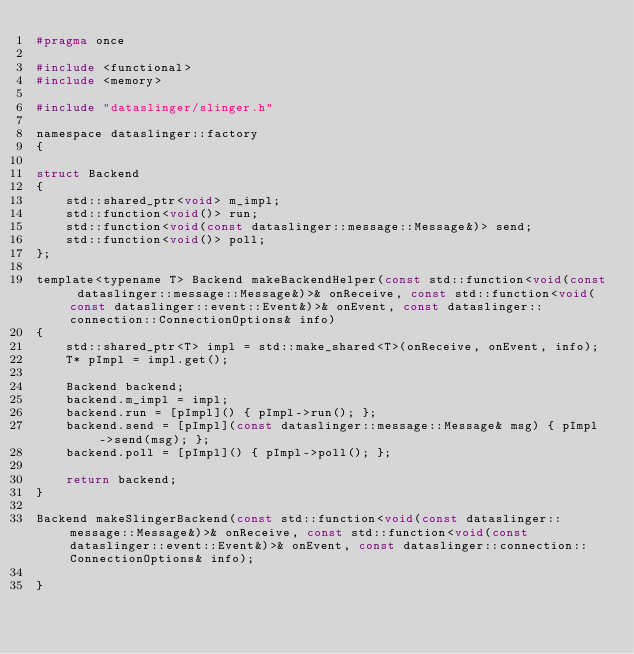Convert code to text. <code><loc_0><loc_0><loc_500><loc_500><_C_>#pragma once

#include <functional>
#include <memory>

#include "dataslinger/slinger.h"

namespace dataslinger::factory
{

struct Backend
{
    std::shared_ptr<void> m_impl;
    std::function<void()> run;
    std::function<void(const dataslinger::message::Message&)> send;
    std::function<void()> poll;
};

template<typename T> Backend makeBackendHelper(const std::function<void(const dataslinger::message::Message&)>& onReceive, const std::function<void(const dataslinger::event::Event&)>& onEvent, const dataslinger::connection::ConnectionOptions& info)
{
    std::shared_ptr<T> impl = std::make_shared<T>(onReceive, onEvent, info);
    T* pImpl = impl.get();

    Backend backend;
    backend.m_impl = impl;
    backend.run = [pImpl]() { pImpl->run(); };
    backend.send = [pImpl](const dataslinger::message::Message& msg) { pImpl->send(msg); };
    backend.poll = [pImpl]() { pImpl->poll(); };

    return backend;
}

Backend makeSlingerBackend(const std::function<void(const dataslinger::message::Message&)>& onReceive, const std::function<void(const dataslinger::event::Event&)>& onEvent, const dataslinger::connection::ConnectionOptions& info);

}
</code> 